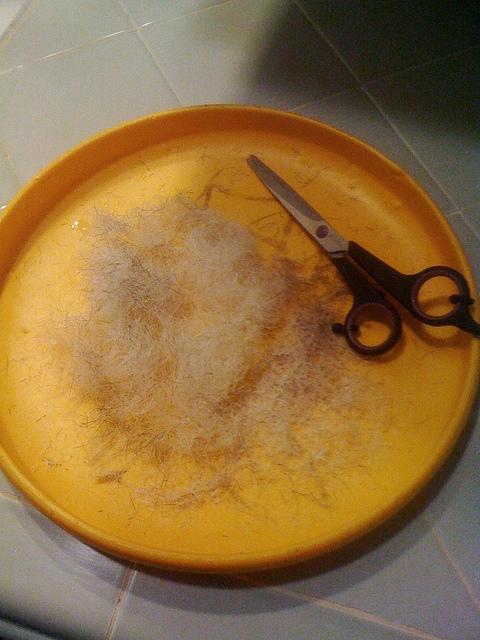Something round and something sharp?
Short answer required. Yes. Is there fur on the image?
Be succinct. Yes. Where are the scissors?
Concise answer only. On plate. 